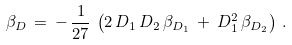<formula> <loc_0><loc_0><loc_500><loc_500>\beta _ { D } \, = \, - \, \frac { 1 } { 2 7 } \, \left ( 2 \, D _ { 1 } \, D _ { 2 } \, \beta _ { D _ { 1 } } \, + \, D _ { 1 } ^ { 2 } \, \beta _ { D _ { 2 } } \right ) \, .</formula> 